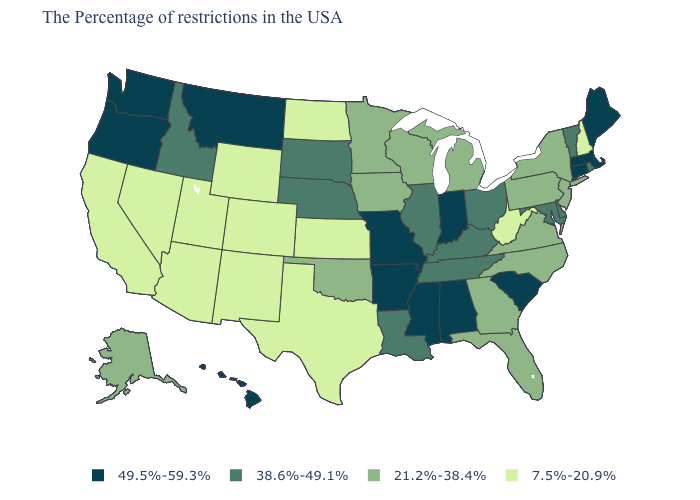What is the highest value in the USA?
Be succinct. 49.5%-59.3%. What is the value of Idaho?
Quick response, please. 38.6%-49.1%. Name the states that have a value in the range 21.2%-38.4%?
Short answer required. New York, New Jersey, Pennsylvania, Virginia, North Carolina, Florida, Georgia, Michigan, Wisconsin, Minnesota, Iowa, Oklahoma, Alaska. Name the states that have a value in the range 49.5%-59.3%?
Short answer required. Maine, Massachusetts, Connecticut, South Carolina, Indiana, Alabama, Mississippi, Missouri, Arkansas, Montana, Washington, Oregon, Hawaii. Name the states that have a value in the range 49.5%-59.3%?
Short answer required. Maine, Massachusetts, Connecticut, South Carolina, Indiana, Alabama, Mississippi, Missouri, Arkansas, Montana, Washington, Oregon, Hawaii. Among the states that border Texas , does Arkansas have the highest value?
Give a very brief answer. Yes. Does Arkansas have a higher value than South Carolina?
Write a very short answer. No. Does Oregon have a higher value than Indiana?
Write a very short answer. No. Which states have the lowest value in the MidWest?
Short answer required. Kansas, North Dakota. Which states have the lowest value in the MidWest?
Answer briefly. Kansas, North Dakota. Does Washington have the highest value in the West?
Keep it brief. Yes. Which states have the lowest value in the USA?
Give a very brief answer. New Hampshire, West Virginia, Kansas, Texas, North Dakota, Wyoming, Colorado, New Mexico, Utah, Arizona, Nevada, California. What is the lowest value in the USA?
Answer briefly. 7.5%-20.9%. Does Texas have the lowest value in the South?
Write a very short answer. Yes. 